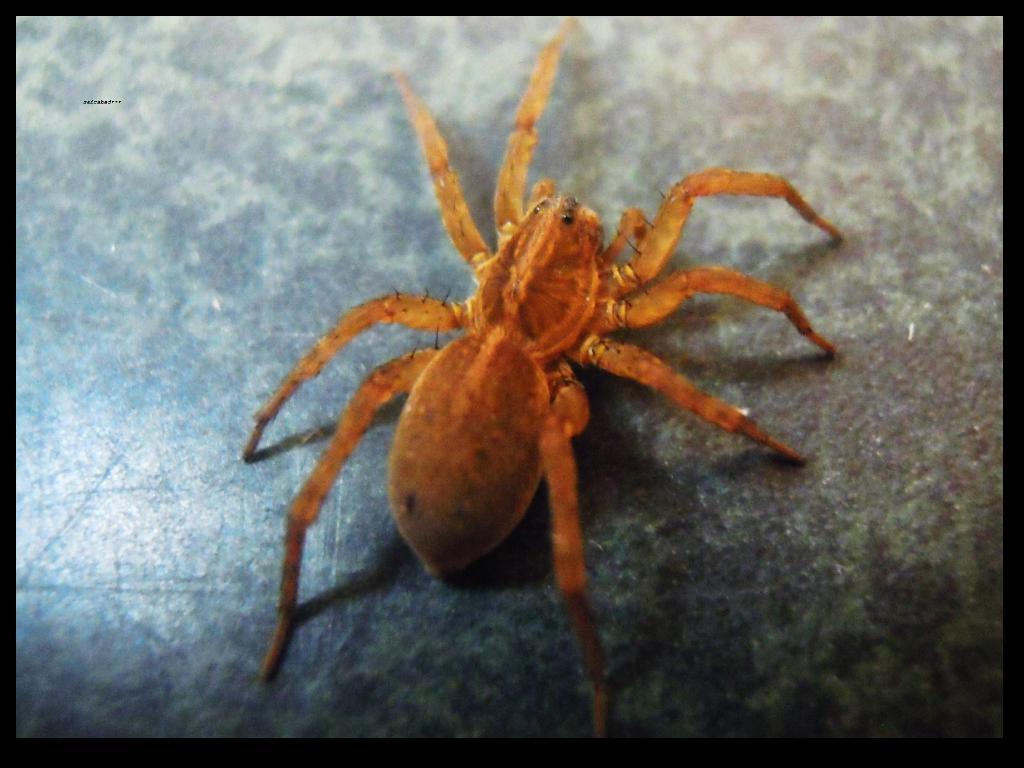Please provide a concise description of this image. This picture shows spider on the table. It is orange in color. 